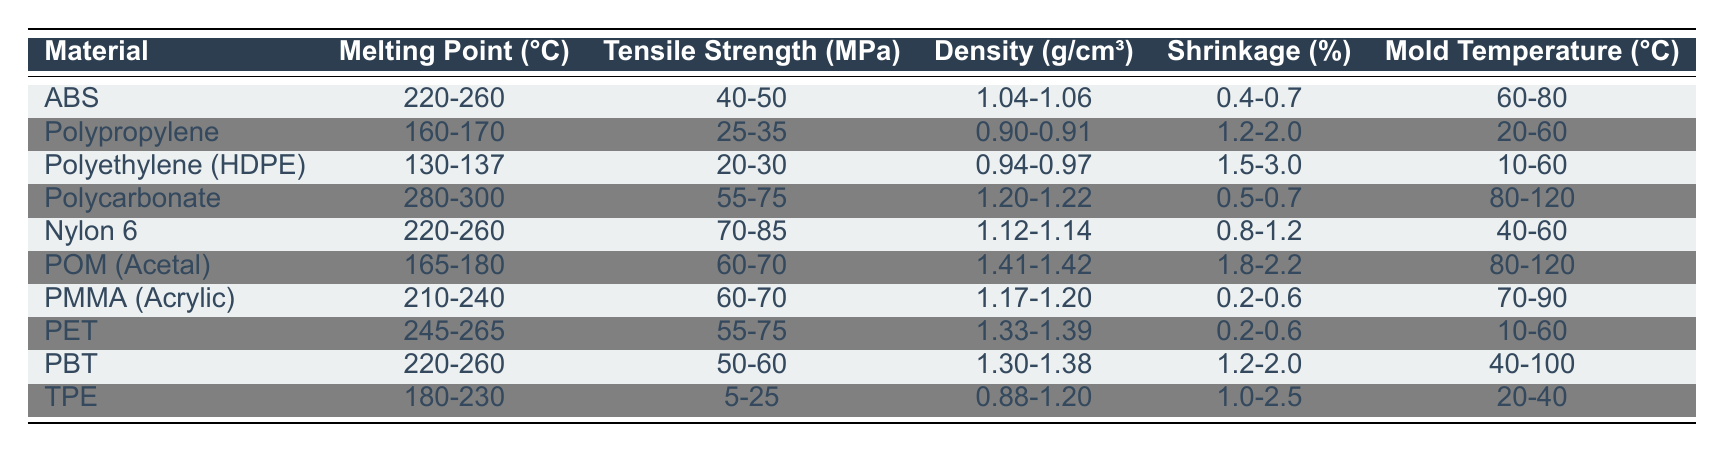What is the melting point range of Polypropylene? The melting point range for Polypropylene is listed in the table as 160-170 °C.
Answer: 160-170 °C Which material has the highest tensile strength? By reviewing the tensile strength values, Nylon 6 has a range of 70-85 MPa, which is the highest compared to the other materials.
Answer: Nylon 6 What is the average density of the materials listed? To find the average density, I calculate the density for each material and average the values: (1.05 + 0.905 + 0.955 + 1.21 + 1.13 + 1.415 + 1.185 + 1.36 + 1.34 + 1.04) / 10 = 1.12 g/cm³.
Answer: 1.12 g/cm³ Is it true that both PMMA and PET have the same mold temperature range? Checking the mold temperature range for PMMA, it is 70-90 °C, while PET's range is 10-60 °C. They do not have the same range, so the statement is false.
Answer: No Which material has the lowest shrinkage percentage? The shrinkage percentage is lowest for PMMA, which has a range of 0.2-0.6%. Thus, it has the lowest shrinkage among the materials listed.
Answer: PMMA What is the total tensile strength range when combining POM and Nylon 6? POM has a tensile strength range of 60-70 MPa and Nylon 6 has a range of 70-85 MPa. To combine these ranges, I take the lowest value of POM (60) and combine it with the highest value of Nylon 6 (85) to get a total strength range of 60-85 MPa.
Answer: 60-85 MPa Which material has a melting point higher than 250 °C? By examining the table, I find that Polycarbonate has a melting point range of 280-300 °C, which is higher than 250 °C.
Answer: Polycarbonate Is the density of POM greater than that of Polypropylene? POM has a density of 1.41-1.42 g/cm³, while Polypropylene has a density of 0.90-0.91 g/cm³, showing that POM's density is indeed greater.
Answer: Yes 